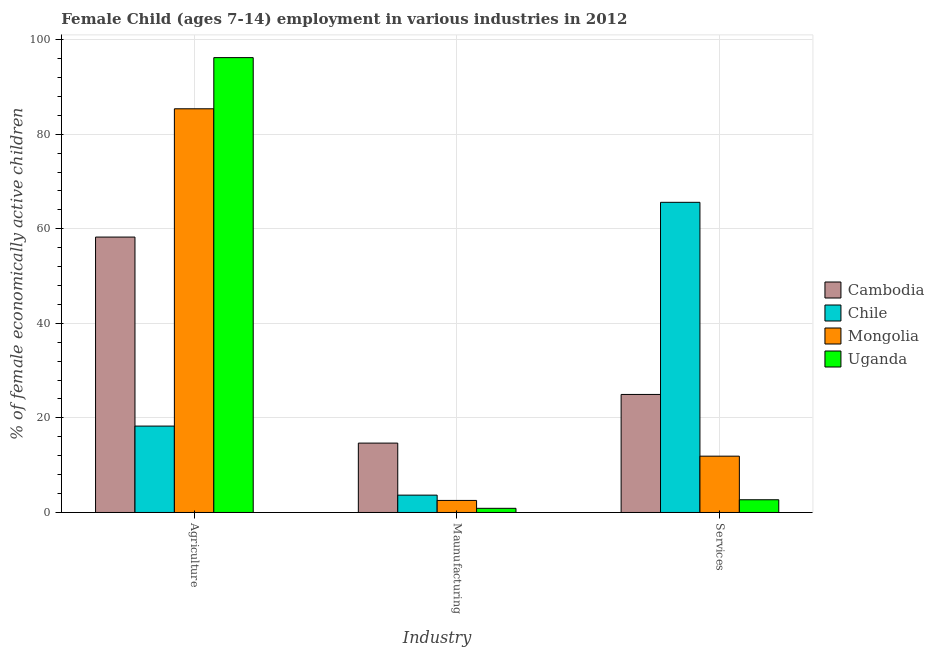How many different coloured bars are there?
Provide a succinct answer. 4. Are the number of bars per tick equal to the number of legend labels?
Keep it short and to the point. Yes. Are the number of bars on each tick of the X-axis equal?
Your answer should be compact. Yes. What is the label of the 3rd group of bars from the left?
Keep it short and to the point. Services. What is the percentage of economically active children in manufacturing in Uganda?
Your answer should be very brief. 0.88. Across all countries, what is the maximum percentage of economically active children in agriculture?
Your answer should be compact. 96.19. Across all countries, what is the minimum percentage of economically active children in services?
Offer a very short reply. 2.69. In which country was the percentage of economically active children in manufacturing maximum?
Ensure brevity in your answer.  Cambodia. In which country was the percentage of economically active children in services minimum?
Your answer should be compact. Uganda. What is the total percentage of economically active children in services in the graph?
Provide a succinct answer. 105.15. What is the difference between the percentage of economically active children in agriculture in Mongolia and that in Uganda?
Provide a short and direct response. -10.82. What is the difference between the percentage of economically active children in services in Mongolia and the percentage of economically active children in manufacturing in Chile?
Ensure brevity in your answer.  8.24. What is the average percentage of economically active children in agriculture per country?
Provide a succinct answer. 64.52. What is the difference between the percentage of economically active children in manufacturing and percentage of economically active children in agriculture in Chile?
Keep it short and to the point. -14.6. What is the ratio of the percentage of economically active children in manufacturing in Chile to that in Mongolia?
Provide a succinct answer. 1.44. Is the percentage of economically active children in manufacturing in Chile less than that in Mongolia?
Offer a terse response. No. Is the difference between the percentage of economically active children in services in Cambodia and Mongolia greater than the difference between the percentage of economically active children in agriculture in Cambodia and Mongolia?
Offer a very short reply. Yes. What is the difference between the highest and the second highest percentage of economically active children in services?
Keep it short and to the point. 40.63. What is the difference between the highest and the lowest percentage of economically active children in manufacturing?
Provide a succinct answer. 13.79. In how many countries, is the percentage of economically active children in manufacturing greater than the average percentage of economically active children in manufacturing taken over all countries?
Your response must be concise. 1. What does the 1st bar from the left in Maunufacturing represents?
Offer a very short reply. Cambodia. What does the 2nd bar from the right in Services represents?
Your answer should be compact. Mongolia. Is it the case that in every country, the sum of the percentage of economically active children in agriculture and percentage of economically active children in manufacturing is greater than the percentage of economically active children in services?
Make the answer very short. No. Are all the bars in the graph horizontal?
Offer a terse response. No. How many countries are there in the graph?
Make the answer very short. 4. Are the values on the major ticks of Y-axis written in scientific E-notation?
Offer a terse response. No. Where does the legend appear in the graph?
Provide a succinct answer. Center right. How are the legend labels stacked?
Your answer should be very brief. Vertical. What is the title of the graph?
Ensure brevity in your answer.  Female Child (ages 7-14) employment in various industries in 2012. Does "Mozambique" appear as one of the legend labels in the graph?
Provide a succinct answer. No. What is the label or title of the X-axis?
Your answer should be compact. Industry. What is the label or title of the Y-axis?
Ensure brevity in your answer.  % of female economically active children. What is the % of female economically active children in Cambodia in Agriculture?
Make the answer very short. 58.24. What is the % of female economically active children in Chile in Agriculture?
Keep it short and to the point. 18.27. What is the % of female economically active children of Mongolia in Agriculture?
Keep it short and to the point. 85.37. What is the % of female economically active children of Uganda in Agriculture?
Offer a terse response. 96.19. What is the % of female economically active children in Cambodia in Maunufacturing?
Provide a short and direct response. 14.67. What is the % of female economically active children in Chile in Maunufacturing?
Offer a very short reply. 3.67. What is the % of female economically active children in Mongolia in Maunufacturing?
Offer a terse response. 2.55. What is the % of female economically active children in Uganda in Maunufacturing?
Your response must be concise. 0.88. What is the % of female economically active children of Cambodia in Services?
Offer a very short reply. 24.96. What is the % of female economically active children in Chile in Services?
Your answer should be very brief. 65.59. What is the % of female economically active children in Mongolia in Services?
Keep it short and to the point. 11.91. What is the % of female economically active children of Uganda in Services?
Provide a succinct answer. 2.69. Across all Industry, what is the maximum % of female economically active children of Cambodia?
Ensure brevity in your answer.  58.24. Across all Industry, what is the maximum % of female economically active children of Chile?
Give a very brief answer. 65.59. Across all Industry, what is the maximum % of female economically active children in Mongolia?
Give a very brief answer. 85.37. Across all Industry, what is the maximum % of female economically active children of Uganda?
Offer a terse response. 96.19. Across all Industry, what is the minimum % of female economically active children in Cambodia?
Keep it short and to the point. 14.67. Across all Industry, what is the minimum % of female economically active children in Chile?
Give a very brief answer. 3.67. Across all Industry, what is the minimum % of female economically active children in Mongolia?
Your answer should be very brief. 2.55. What is the total % of female economically active children in Cambodia in the graph?
Your answer should be very brief. 97.87. What is the total % of female economically active children of Chile in the graph?
Make the answer very short. 87.53. What is the total % of female economically active children of Mongolia in the graph?
Make the answer very short. 99.83. What is the total % of female economically active children in Uganda in the graph?
Offer a terse response. 99.76. What is the difference between the % of female economically active children in Cambodia in Agriculture and that in Maunufacturing?
Give a very brief answer. 43.57. What is the difference between the % of female economically active children in Chile in Agriculture and that in Maunufacturing?
Ensure brevity in your answer.  14.6. What is the difference between the % of female economically active children in Mongolia in Agriculture and that in Maunufacturing?
Provide a short and direct response. 82.82. What is the difference between the % of female economically active children in Uganda in Agriculture and that in Maunufacturing?
Your response must be concise. 95.31. What is the difference between the % of female economically active children in Cambodia in Agriculture and that in Services?
Provide a succinct answer. 33.28. What is the difference between the % of female economically active children in Chile in Agriculture and that in Services?
Keep it short and to the point. -47.32. What is the difference between the % of female economically active children in Mongolia in Agriculture and that in Services?
Offer a terse response. 73.46. What is the difference between the % of female economically active children in Uganda in Agriculture and that in Services?
Ensure brevity in your answer.  93.5. What is the difference between the % of female economically active children in Cambodia in Maunufacturing and that in Services?
Offer a very short reply. -10.29. What is the difference between the % of female economically active children in Chile in Maunufacturing and that in Services?
Your answer should be compact. -61.92. What is the difference between the % of female economically active children in Mongolia in Maunufacturing and that in Services?
Ensure brevity in your answer.  -9.36. What is the difference between the % of female economically active children in Uganda in Maunufacturing and that in Services?
Your answer should be compact. -1.81. What is the difference between the % of female economically active children of Cambodia in Agriculture and the % of female economically active children of Chile in Maunufacturing?
Your response must be concise. 54.57. What is the difference between the % of female economically active children of Cambodia in Agriculture and the % of female economically active children of Mongolia in Maunufacturing?
Keep it short and to the point. 55.69. What is the difference between the % of female economically active children in Cambodia in Agriculture and the % of female economically active children in Uganda in Maunufacturing?
Give a very brief answer. 57.36. What is the difference between the % of female economically active children in Chile in Agriculture and the % of female economically active children in Mongolia in Maunufacturing?
Make the answer very short. 15.72. What is the difference between the % of female economically active children in Chile in Agriculture and the % of female economically active children in Uganda in Maunufacturing?
Provide a succinct answer. 17.39. What is the difference between the % of female economically active children in Mongolia in Agriculture and the % of female economically active children in Uganda in Maunufacturing?
Offer a terse response. 84.49. What is the difference between the % of female economically active children in Cambodia in Agriculture and the % of female economically active children in Chile in Services?
Your answer should be very brief. -7.35. What is the difference between the % of female economically active children of Cambodia in Agriculture and the % of female economically active children of Mongolia in Services?
Offer a very short reply. 46.33. What is the difference between the % of female economically active children of Cambodia in Agriculture and the % of female economically active children of Uganda in Services?
Provide a short and direct response. 55.55. What is the difference between the % of female economically active children in Chile in Agriculture and the % of female economically active children in Mongolia in Services?
Give a very brief answer. 6.36. What is the difference between the % of female economically active children of Chile in Agriculture and the % of female economically active children of Uganda in Services?
Give a very brief answer. 15.58. What is the difference between the % of female economically active children in Mongolia in Agriculture and the % of female economically active children in Uganda in Services?
Give a very brief answer. 82.68. What is the difference between the % of female economically active children of Cambodia in Maunufacturing and the % of female economically active children of Chile in Services?
Ensure brevity in your answer.  -50.92. What is the difference between the % of female economically active children of Cambodia in Maunufacturing and the % of female economically active children of Mongolia in Services?
Keep it short and to the point. 2.76. What is the difference between the % of female economically active children of Cambodia in Maunufacturing and the % of female economically active children of Uganda in Services?
Provide a succinct answer. 11.98. What is the difference between the % of female economically active children in Chile in Maunufacturing and the % of female economically active children in Mongolia in Services?
Give a very brief answer. -8.24. What is the difference between the % of female economically active children of Chile in Maunufacturing and the % of female economically active children of Uganda in Services?
Provide a short and direct response. 0.98. What is the difference between the % of female economically active children in Mongolia in Maunufacturing and the % of female economically active children in Uganda in Services?
Offer a terse response. -0.14. What is the average % of female economically active children of Cambodia per Industry?
Make the answer very short. 32.62. What is the average % of female economically active children in Chile per Industry?
Give a very brief answer. 29.18. What is the average % of female economically active children of Mongolia per Industry?
Ensure brevity in your answer.  33.28. What is the average % of female economically active children in Uganda per Industry?
Make the answer very short. 33.25. What is the difference between the % of female economically active children of Cambodia and % of female economically active children of Chile in Agriculture?
Your answer should be very brief. 39.97. What is the difference between the % of female economically active children in Cambodia and % of female economically active children in Mongolia in Agriculture?
Make the answer very short. -27.13. What is the difference between the % of female economically active children of Cambodia and % of female economically active children of Uganda in Agriculture?
Provide a succinct answer. -37.95. What is the difference between the % of female economically active children of Chile and % of female economically active children of Mongolia in Agriculture?
Provide a short and direct response. -67.1. What is the difference between the % of female economically active children in Chile and % of female economically active children in Uganda in Agriculture?
Keep it short and to the point. -77.92. What is the difference between the % of female economically active children of Mongolia and % of female economically active children of Uganda in Agriculture?
Offer a very short reply. -10.82. What is the difference between the % of female economically active children in Cambodia and % of female economically active children in Chile in Maunufacturing?
Keep it short and to the point. 11. What is the difference between the % of female economically active children in Cambodia and % of female economically active children in Mongolia in Maunufacturing?
Your answer should be compact. 12.12. What is the difference between the % of female economically active children in Cambodia and % of female economically active children in Uganda in Maunufacturing?
Your response must be concise. 13.79. What is the difference between the % of female economically active children in Chile and % of female economically active children in Mongolia in Maunufacturing?
Offer a very short reply. 1.12. What is the difference between the % of female economically active children of Chile and % of female economically active children of Uganda in Maunufacturing?
Make the answer very short. 2.79. What is the difference between the % of female economically active children of Mongolia and % of female economically active children of Uganda in Maunufacturing?
Give a very brief answer. 1.67. What is the difference between the % of female economically active children of Cambodia and % of female economically active children of Chile in Services?
Provide a short and direct response. -40.63. What is the difference between the % of female economically active children in Cambodia and % of female economically active children in Mongolia in Services?
Give a very brief answer. 13.05. What is the difference between the % of female economically active children in Cambodia and % of female economically active children in Uganda in Services?
Your response must be concise. 22.27. What is the difference between the % of female economically active children of Chile and % of female economically active children of Mongolia in Services?
Provide a succinct answer. 53.68. What is the difference between the % of female economically active children of Chile and % of female economically active children of Uganda in Services?
Your answer should be very brief. 62.9. What is the difference between the % of female economically active children of Mongolia and % of female economically active children of Uganda in Services?
Ensure brevity in your answer.  9.22. What is the ratio of the % of female economically active children of Cambodia in Agriculture to that in Maunufacturing?
Offer a terse response. 3.97. What is the ratio of the % of female economically active children of Chile in Agriculture to that in Maunufacturing?
Your answer should be compact. 4.98. What is the ratio of the % of female economically active children in Mongolia in Agriculture to that in Maunufacturing?
Make the answer very short. 33.48. What is the ratio of the % of female economically active children of Uganda in Agriculture to that in Maunufacturing?
Your answer should be very brief. 109.31. What is the ratio of the % of female economically active children of Cambodia in Agriculture to that in Services?
Make the answer very short. 2.33. What is the ratio of the % of female economically active children of Chile in Agriculture to that in Services?
Make the answer very short. 0.28. What is the ratio of the % of female economically active children in Mongolia in Agriculture to that in Services?
Your response must be concise. 7.17. What is the ratio of the % of female economically active children of Uganda in Agriculture to that in Services?
Provide a short and direct response. 35.76. What is the ratio of the % of female economically active children of Cambodia in Maunufacturing to that in Services?
Your response must be concise. 0.59. What is the ratio of the % of female economically active children of Chile in Maunufacturing to that in Services?
Provide a succinct answer. 0.06. What is the ratio of the % of female economically active children in Mongolia in Maunufacturing to that in Services?
Your response must be concise. 0.21. What is the ratio of the % of female economically active children of Uganda in Maunufacturing to that in Services?
Offer a terse response. 0.33. What is the difference between the highest and the second highest % of female economically active children of Cambodia?
Provide a succinct answer. 33.28. What is the difference between the highest and the second highest % of female economically active children of Chile?
Offer a very short reply. 47.32. What is the difference between the highest and the second highest % of female economically active children of Mongolia?
Offer a terse response. 73.46. What is the difference between the highest and the second highest % of female economically active children of Uganda?
Provide a short and direct response. 93.5. What is the difference between the highest and the lowest % of female economically active children of Cambodia?
Make the answer very short. 43.57. What is the difference between the highest and the lowest % of female economically active children in Chile?
Offer a very short reply. 61.92. What is the difference between the highest and the lowest % of female economically active children in Mongolia?
Offer a terse response. 82.82. What is the difference between the highest and the lowest % of female economically active children of Uganda?
Your answer should be very brief. 95.31. 